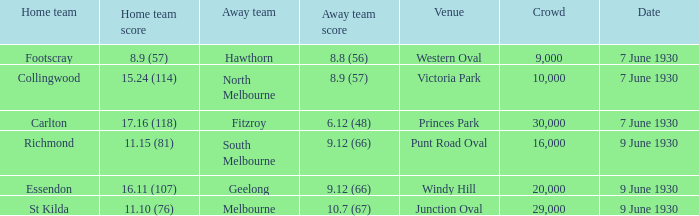Which opposing team played against footscray? Hawthorn. 